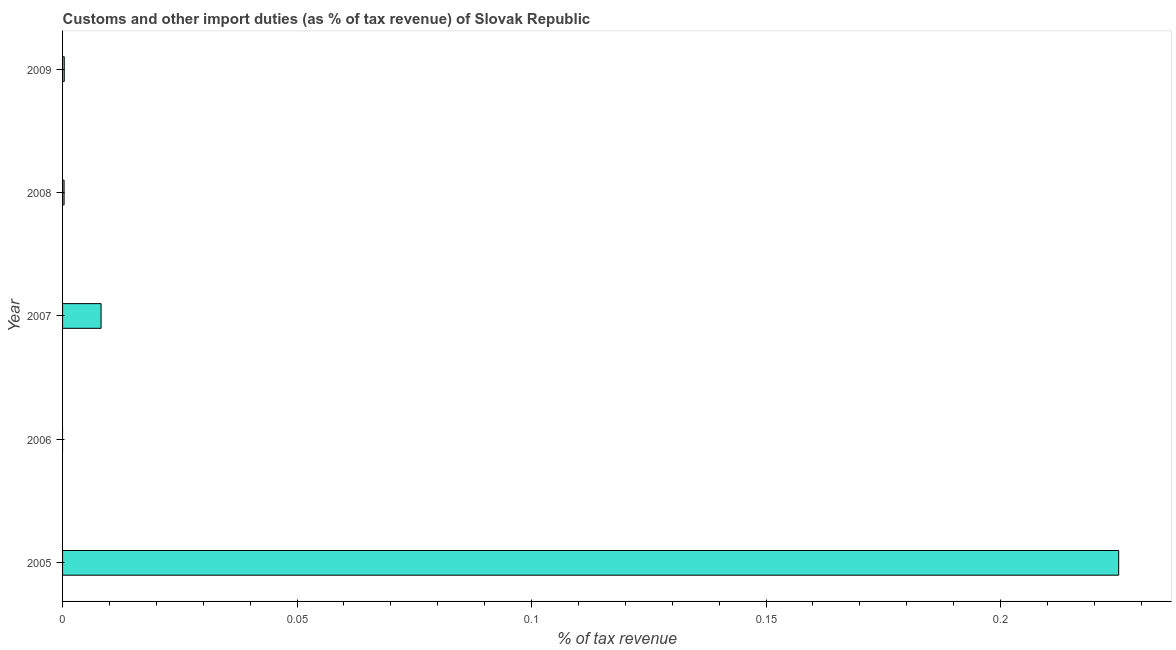Does the graph contain any zero values?
Your answer should be compact. Yes. Does the graph contain grids?
Give a very brief answer. No. What is the title of the graph?
Offer a terse response. Customs and other import duties (as % of tax revenue) of Slovak Republic. What is the label or title of the X-axis?
Provide a short and direct response. % of tax revenue. What is the label or title of the Y-axis?
Give a very brief answer. Year. What is the customs and other import duties in 2005?
Provide a succinct answer. 0.23. Across all years, what is the maximum customs and other import duties?
Offer a very short reply. 0.23. In which year was the customs and other import duties maximum?
Offer a very short reply. 2005. What is the sum of the customs and other import duties?
Offer a very short reply. 0.23. What is the difference between the customs and other import duties in 2005 and 2009?
Offer a very short reply. 0.23. What is the average customs and other import duties per year?
Offer a very short reply. 0.05. What is the median customs and other import duties?
Make the answer very short. 0. In how many years, is the customs and other import duties greater than 0.11 %?
Ensure brevity in your answer.  1. What is the ratio of the customs and other import duties in 2007 to that in 2008?
Your answer should be very brief. 25.56. Is the customs and other import duties in 2008 less than that in 2009?
Your answer should be very brief. Yes. Is the difference between the customs and other import duties in 2005 and 2007 greater than the difference between any two years?
Your response must be concise. No. What is the difference between the highest and the second highest customs and other import duties?
Provide a succinct answer. 0.22. What is the difference between the highest and the lowest customs and other import duties?
Your answer should be compact. 0.23. How many bars are there?
Offer a terse response. 4. Are all the bars in the graph horizontal?
Your answer should be compact. Yes. How many years are there in the graph?
Give a very brief answer. 5. What is the difference between two consecutive major ticks on the X-axis?
Your answer should be compact. 0.05. What is the % of tax revenue of 2005?
Your answer should be compact. 0.23. What is the % of tax revenue in 2007?
Provide a short and direct response. 0.01. What is the % of tax revenue in 2008?
Offer a terse response. 0. What is the % of tax revenue in 2009?
Your answer should be very brief. 0. What is the difference between the % of tax revenue in 2005 and 2007?
Your answer should be compact. 0.22. What is the difference between the % of tax revenue in 2005 and 2008?
Offer a very short reply. 0.22. What is the difference between the % of tax revenue in 2005 and 2009?
Give a very brief answer. 0.22. What is the difference between the % of tax revenue in 2007 and 2008?
Offer a terse response. 0.01. What is the difference between the % of tax revenue in 2007 and 2009?
Ensure brevity in your answer.  0.01. What is the difference between the % of tax revenue in 2008 and 2009?
Ensure brevity in your answer.  -4e-5. What is the ratio of the % of tax revenue in 2005 to that in 2007?
Offer a very short reply. 27.43. What is the ratio of the % of tax revenue in 2005 to that in 2008?
Provide a short and direct response. 701.22. What is the ratio of the % of tax revenue in 2005 to that in 2009?
Offer a very short reply. 627.91. What is the ratio of the % of tax revenue in 2007 to that in 2008?
Ensure brevity in your answer.  25.56. What is the ratio of the % of tax revenue in 2007 to that in 2009?
Make the answer very short. 22.89. What is the ratio of the % of tax revenue in 2008 to that in 2009?
Your answer should be compact. 0.9. 